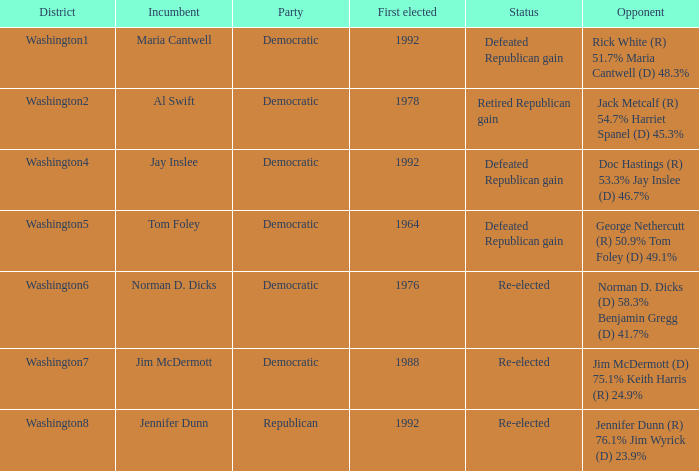7%? Defeated Republican gain. 